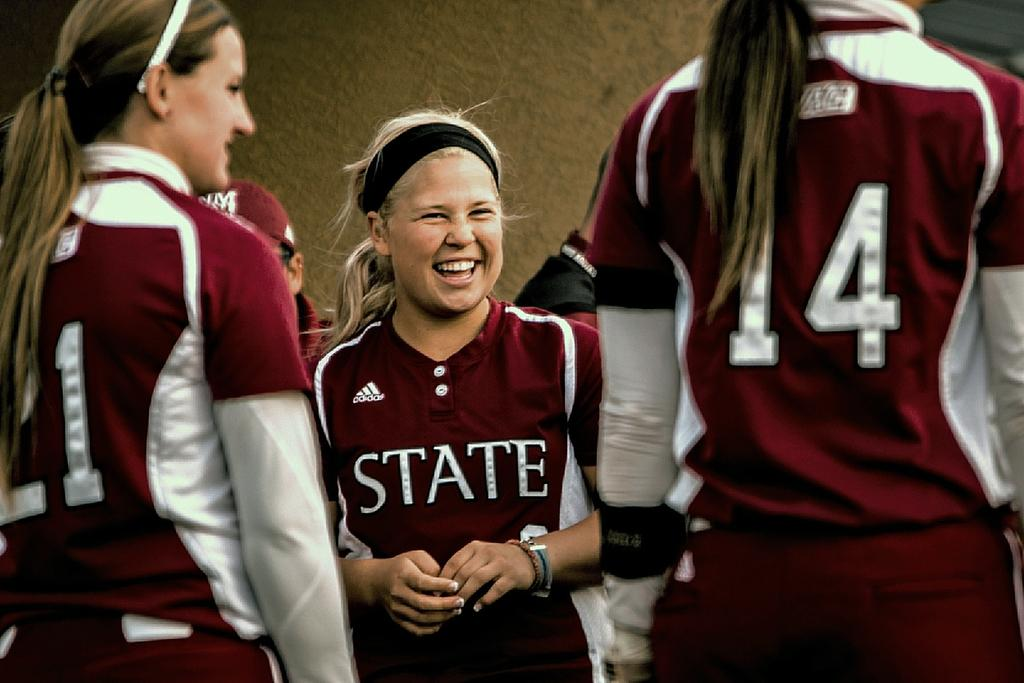<image>
Create a compact narrative representing the image presented. The blond girl in the middle has a shirt on the has STATE written across the front of it. 